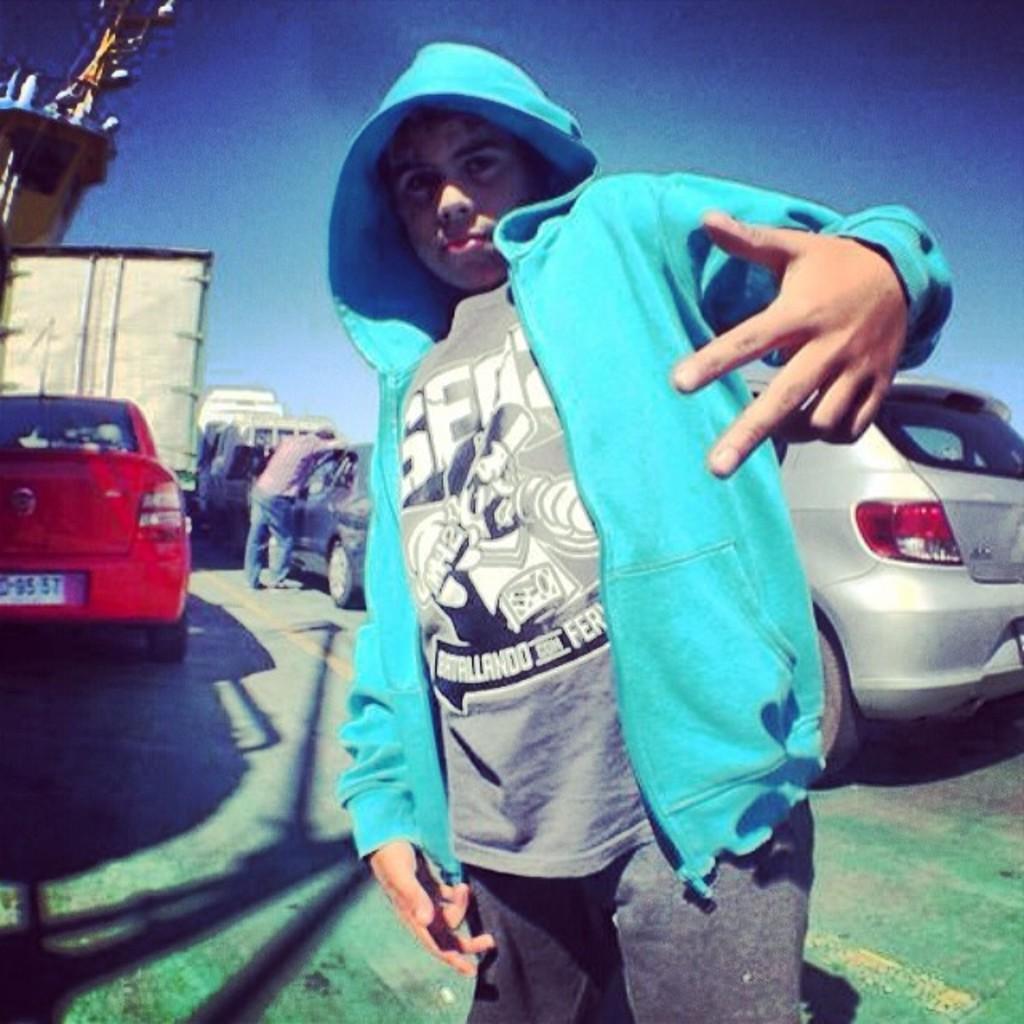In one or two sentences, can you explain what this image depicts? In this picture there is a man standing in the foreground. At the back there are vehicles on the road and there is a man standing on the road. At the top there is sky. At the bottom there is a road. 